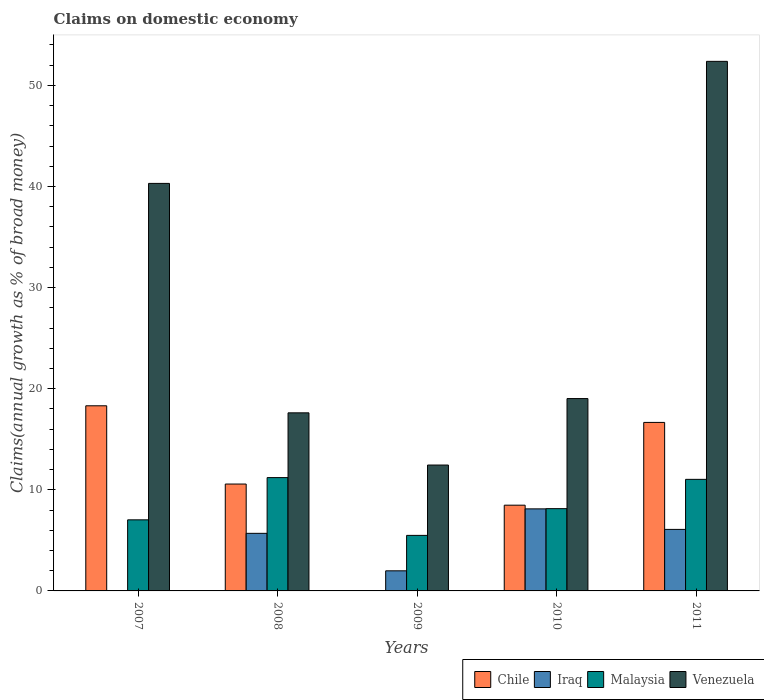How many different coloured bars are there?
Ensure brevity in your answer.  4. How many bars are there on the 5th tick from the left?
Your answer should be very brief. 4. How many bars are there on the 5th tick from the right?
Your answer should be compact. 3. In how many cases, is the number of bars for a given year not equal to the number of legend labels?
Your answer should be compact. 2. What is the percentage of broad money claimed on domestic economy in Chile in 2009?
Offer a terse response. 0. Across all years, what is the maximum percentage of broad money claimed on domestic economy in Venezuela?
Make the answer very short. 52.38. What is the total percentage of broad money claimed on domestic economy in Chile in the graph?
Give a very brief answer. 54.03. What is the difference between the percentage of broad money claimed on domestic economy in Malaysia in 2010 and that in 2011?
Offer a terse response. -2.9. What is the difference between the percentage of broad money claimed on domestic economy in Venezuela in 2008 and the percentage of broad money claimed on domestic economy in Malaysia in 2010?
Give a very brief answer. 9.48. What is the average percentage of broad money claimed on domestic economy in Malaysia per year?
Your answer should be very brief. 8.58. In the year 2011, what is the difference between the percentage of broad money claimed on domestic economy in Venezuela and percentage of broad money claimed on domestic economy in Chile?
Provide a short and direct response. 35.71. In how many years, is the percentage of broad money claimed on domestic economy in Chile greater than 2 %?
Ensure brevity in your answer.  4. What is the ratio of the percentage of broad money claimed on domestic economy in Malaysia in 2007 to that in 2008?
Make the answer very short. 0.63. Is the percentage of broad money claimed on domestic economy in Iraq in 2010 less than that in 2011?
Offer a terse response. No. Is the difference between the percentage of broad money claimed on domestic economy in Venezuela in 2007 and 2008 greater than the difference between the percentage of broad money claimed on domestic economy in Chile in 2007 and 2008?
Offer a terse response. Yes. What is the difference between the highest and the second highest percentage of broad money claimed on domestic economy in Iraq?
Your answer should be very brief. 2.03. What is the difference between the highest and the lowest percentage of broad money claimed on domestic economy in Chile?
Your response must be concise. 18.31. Is the sum of the percentage of broad money claimed on domestic economy in Venezuela in 2008 and 2009 greater than the maximum percentage of broad money claimed on domestic economy in Malaysia across all years?
Make the answer very short. Yes. Is it the case that in every year, the sum of the percentage of broad money claimed on domestic economy in Malaysia and percentage of broad money claimed on domestic economy in Iraq is greater than the percentage of broad money claimed on domestic economy in Venezuela?
Give a very brief answer. No. How many bars are there?
Your response must be concise. 18. How many years are there in the graph?
Make the answer very short. 5. What is the difference between two consecutive major ticks on the Y-axis?
Make the answer very short. 10. Does the graph contain grids?
Keep it short and to the point. No. Where does the legend appear in the graph?
Offer a very short reply. Bottom right. How many legend labels are there?
Your answer should be compact. 4. What is the title of the graph?
Your answer should be very brief. Claims on domestic economy. What is the label or title of the X-axis?
Keep it short and to the point. Years. What is the label or title of the Y-axis?
Offer a very short reply. Claims(annual growth as % of broad money). What is the Claims(annual growth as % of broad money) of Chile in 2007?
Your answer should be compact. 18.31. What is the Claims(annual growth as % of broad money) in Iraq in 2007?
Give a very brief answer. 0. What is the Claims(annual growth as % of broad money) in Malaysia in 2007?
Ensure brevity in your answer.  7.03. What is the Claims(annual growth as % of broad money) in Venezuela in 2007?
Your answer should be compact. 40.31. What is the Claims(annual growth as % of broad money) of Chile in 2008?
Your answer should be very brief. 10.57. What is the Claims(annual growth as % of broad money) of Iraq in 2008?
Ensure brevity in your answer.  5.7. What is the Claims(annual growth as % of broad money) of Malaysia in 2008?
Offer a very short reply. 11.21. What is the Claims(annual growth as % of broad money) in Venezuela in 2008?
Ensure brevity in your answer.  17.61. What is the Claims(annual growth as % of broad money) in Chile in 2009?
Ensure brevity in your answer.  0. What is the Claims(annual growth as % of broad money) in Iraq in 2009?
Keep it short and to the point. 1.99. What is the Claims(annual growth as % of broad money) in Malaysia in 2009?
Provide a succinct answer. 5.49. What is the Claims(annual growth as % of broad money) in Venezuela in 2009?
Provide a succinct answer. 12.45. What is the Claims(annual growth as % of broad money) in Chile in 2010?
Ensure brevity in your answer.  8.48. What is the Claims(annual growth as % of broad money) in Iraq in 2010?
Make the answer very short. 8.12. What is the Claims(annual growth as % of broad money) in Malaysia in 2010?
Provide a short and direct response. 8.14. What is the Claims(annual growth as % of broad money) of Venezuela in 2010?
Give a very brief answer. 19.03. What is the Claims(annual growth as % of broad money) in Chile in 2011?
Keep it short and to the point. 16.67. What is the Claims(annual growth as % of broad money) of Iraq in 2011?
Your answer should be compact. 6.09. What is the Claims(annual growth as % of broad money) in Malaysia in 2011?
Provide a short and direct response. 11.04. What is the Claims(annual growth as % of broad money) of Venezuela in 2011?
Provide a succinct answer. 52.38. Across all years, what is the maximum Claims(annual growth as % of broad money) of Chile?
Your response must be concise. 18.31. Across all years, what is the maximum Claims(annual growth as % of broad money) of Iraq?
Provide a succinct answer. 8.12. Across all years, what is the maximum Claims(annual growth as % of broad money) of Malaysia?
Provide a short and direct response. 11.21. Across all years, what is the maximum Claims(annual growth as % of broad money) of Venezuela?
Provide a succinct answer. 52.38. Across all years, what is the minimum Claims(annual growth as % of broad money) of Chile?
Your answer should be compact. 0. Across all years, what is the minimum Claims(annual growth as % of broad money) in Iraq?
Your answer should be compact. 0. Across all years, what is the minimum Claims(annual growth as % of broad money) in Malaysia?
Keep it short and to the point. 5.49. Across all years, what is the minimum Claims(annual growth as % of broad money) in Venezuela?
Ensure brevity in your answer.  12.45. What is the total Claims(annual growth as % of broad money) of Chile in the graph?
Keep it short and to the point. 54.03. What is the total Claims(annual growth as % of broad money) in Iraq in the graph?
Your answer should be compact. 21.88. What is the total Claims(annual growth as % of broad money) in Malaysia in the graph?
Offer a very short reply. 42.9. What is the total Claims(annual growth as % of broad money) in Venezuela in the graph?
Give a very brief answer. 141.78. What is the difference between the Claims(annual growth as % of broad money) in Chile in 2007 and that in 2008?
Your response must be concise. 7.74. What is the difference between the Claims(annual growth as % of broad money) of Malaysia in 2007 and that in 2008?
Provide a succinct answer. -4.18. What is the difference between the Claims(annual growth as % of broad money) in Venezuela in 2007 and that in 2008?
Provide a succinct answer. 22.69. What is the difference between the Claims(annual growth as % of broad money) in Malaysia in 2007 and that in 2009?
Make the answer very short. 1.54. What is the difference between the Claims(annual growth as % of broad money) in Venezuela in 2007 and that in 2009?
Provide a succinct answer. 27.86. What is the difference between the Claims(annual growth as % of broad money) of Chile in 2007 and that in 2010?
Your answer should be compact. 9.83. What is the difference between the Claims(annual growth as % of broad money) in Malaysia in 2007 and that in 2010?
Your response must be concise. -1.11. What is the difference between the Claims(annual growth as % of broad money) of Venezuela in 2007 and that in 2010?
Your answer should be compact. 21.28. What is the difference between the Claims(annual growth as % of broad money) in Chile in 2007 and that in 2011?
Provide a short and direct response. 1.65. What is the difference between the Claims(annual growth as % of broad money) in Malaysia in 2007 and that in 2011?
Offer a very short reply. -4.01. What is the difference between the Claims(annual growth as % of broad money) in Venezuela in 2007 and that in 2011?
Your answer should be compact. -12.07. What is the difference between the Claims(annual growth as % of broad money) in Iraq in 2008 and that in 2009?
Your answer should be compact. 3.71. What is the difference between the Claims(annual growth as % of broad money) of Malaysia in 2008 and that in 2009?
Ensure brevity in your answer.  5.72. What is the difference between the Claims(annual growth as % of broad money) of Venezuela in 2008 and that in 2009?
Your response must be concise. 5.16. What is the difference between the Claims(annual growth as % of broad money) of Chile in 2008 and that in 2010?
Keep it short and to the point. 2.09. What is the difference between the Claims(annual growth as % of broad money) of Iraq in 2008 and that in 2010?
Provide a succinct answer. -2.42. What is the difference between the Claims(annual growth as % of broad money) in Malaysia in 2008 and that in 2010?
Make the answer very short. 3.07. What is the difference between the Claims(annual growth as % of broad money) in Venezuela in 2008 and that in 2010?
Offer a very short reply. -1.41. What is the difference between the Claims(annual growth as % of broad money) of Chile in 2008 and that in 2011?
Keep it short and to the point. -6.09. What is the difference between the Claims(annual growth as % of broad money) in Iraq in 2008 and that in 2011?
Your answer should be very brief. -0.39. What is the difference between the Claims(annual growth as % of broad money) in Malaysia in 2008 and that in 2011?
Provide a short and direct response. 0.17. What is the difference between the Claims(annual growth as % of broad money) in Venezuela in 2008 and that in 2011?
Your response must be concise. -34.77. What is the difference between the Claims(annual growth as % of broad money) in Iraq in 2009 and that in 2010?
Offer a very short reply. -6.13. What is the difference between the Claims(annual growth as % of broad money) in Malaysia in 2009 and that in 2010?
Your answer should be compact. -2.64. What is the difference between the Claims(annual growth as % of broad money) of Venezuela in 2009 and that in 2010?
Your answer should be compact. -6.57. What is the difference between the Claims(annual growth as % of broad money) of Iraq in 2009 and that in 2011?
Give a very brief answer. -4.1. What is the difference between the Claims(annual growth as % of broad money) in Malaysia in 2009 and that in 2011?
Your response must be concise. -5.54. What is the difference between the Claims(annual growth as % of broad money) in Venezuela in 2009 and that in 2011?
Provide a succinct answer. -39.93. What is the difference between the Claims(annual growth as % of broad money) of Chile in 2010 and that in 2011?
Provide a succinct answer. -8.19. What is the difference between the Claims(annual growth as % of broad money) in Iraq in 2010 and that in 2011?
Your response must be concise. 2.03. What is the difference between the Claims(annual growth as % of broad money) of Malaysia in 2010 and that in 2011?
Make the answer very short. -2.9. What is the difference between the Claims(annual growth as % of broad money) in Venezuela in 2010 and that in 2011?
Your answer should be very brief. -33.35. What is the difference between the Claims(annual growth as % of broad money) in Chile in 2007 and the Claims(annual growth as % of broad money) in Iraq in 2008?
Offer a terse response. 12.62. What is the difference between the Claims(annual growth as % of broad money) in Chile in 2007 and the Claims(annual growth as % of broad money) in Malaysia in 2008?
Your answer should be compact. 7.1. What is the difference between the Claims(annual growth as % of broad money) of Chile in 2007 and the Claims(annual growth as % of broad money) of Venezuela in 2008?
Provide a succinct answer. 0.7. What is the difference between the Claims(annual growth as % of broad money) in Malaysia in 2007 and the Claims(annual growth as % of broad money) in Venezuela in 2008?
Ensure brevity in your answer.  -10.58. What is the difference between the Claims(annual growth as % of broad money) of Chile in 2007 and the Claims(annual growth as % of broad money) of Iraq in 2009?
Ensure brevity in your answer.  16.32. What is the difference between the Claims(annual growth as % of broad money) in Chile in 2007 and the Claims(annual growth as % of broad money) in Malaysia in 2009?
Ensure brevity in your answer.  12.82. What is the difference between the Claims(annual growth as % of broad money) of Chile in 2007 and the Claims(annual growth as % of broad money) of Venezuela in 2009?
Offer a terse response. 5.86. What is the difference between the Claims(annual growth as % of broad money) in Malaysia in 2007 and the Claims(annual growth as % of broad money) in Venezuela in 2009?
Give a very brief answer. -5.42. What is the difference between the Claims(annual growth as % of broad money) of Chile in 2007 and the Claims(annual growth as % of broad money) of Iraq in 2010?
Offer a very short reply. 10.2. What is the difference between the Claims(annual growth as % of broad money) in Chile in 2007 and the Claims(annual growth as % of broad money) in Malaysia in 2010?
Your answer should be compact. 10.17. What is the difference between the Claims(annual growth as % of broad money) in Chile in 2007 and the Claims(annual growth as % of broad money) in Venezuela in 2010?
Provide a succinct answer. -0.71. What is the difference between the Claims(annual growth as % of broad money) of Malaysia in 2007 and the Claims(annual growth as % of broad money) of Venezuela in 2010?
Provide a succinct answer. -12. What is the difference between the Claims(annual growth as % of broad money) in Chile in 2007 and the Claims(annual growth as % of broad money) in Iraq in 2011?
Keep it short and to the point. 12.23. What is the difference between the Claims(annual growth as % of broad money) in Chile in 2007 and the Claims(annual growth as % of broad money) in Malaysia in 2011?
Provide a short and direct response. 7.28. What is the difference between the Claims(annual growth as % of broad money) in Chile in 2007 and the Claims(annual growth as % of broad money) in Venezuela in 2011?
Your answer should be very brief. -34.07. What is the difference between the Claims(annual growth as % of broad money) of Malaysia in 2007 and the Claims(annual growth as % of broad money) of Venezuela in 2011?
Keep it short and to the point. -45.35. What is the difference between the Claims(annual growth as % of broad money) in Chile in 2008 and the Claims(annual growth as % of broad money) in Iraq in 2009?
Give a very brief answer. 8.58. What is the difference between the Claims(annual growth as % of broad money) in Chile in 2008 and the Claims(annual growth as % of broad money) in Malaysia in 2009?
Give a very brief answer. 5.08. What is the difference between the Claims(annual growth as % of broad money) of Chile in 2008 and the Claims(annual growth as % of broad money) of Venezuela in 2009?
Ensure brevity in your answer.  -1.88. What is the difference between the Claims(annual growth as % of broad money) in Iraq in 2008 and the Claims(annual growth as % of broad money) in Malaysia in 2009?
Provide a succinct answer. 0.2. What is the difference between the Claims(annual growth as % of broad money) of Iraq in 2008 and the Claims(annual growth as % of broad money) of Venezuela in 2009?
Your response must be concise. -6.76. What is the difference between the Claims(annual growth as % of broad money) in Malaysia in 2008 and the Claims(annual growth as % of broad money) in Venezuela in 2009?
Ensure brevity in your answer.  -1.24. What is the difference between the Claims(annual growth as % of broad money) in Chile in 2008 and the Claims(annual growth as % of broad money) in Iraq in 2010?
Keep it short and to the point. 2.46. What is the difference between the Claims(annual growth as % of broad money) in Chile in 2008 and the Claims(annual growth as % of broad money) in Malaysia in 2010?
Your response must be concise. 2.43. What is the difference between the Claims(annual growth as % of broad money) of Chile in 2008 and the Claims(annual growth as % of broad money) of Venezuela in 2010?
Make the answer very short. -8.45. What is the difference between the Claims(annual growth as % of broad money) of Iraq in 2008 and the Claims(annual growth as % of broad money) of Malaysia in 2010?
Ensure brevity in your answer.  -2.44. What is the difference between the Claims(annual growth as % of broad money) in Iraq in 2008 and the Claims(annual growth as % of broad money) in Venezuela in 2010?
Provide a short and direct response. -13.33. What is the difference between the Claims(annual growth as % of broad money) in Malaysia in 2008 and the Claims(annual growth as % of broad money) in Venezuela in 2010?
Offer a very short reply. -7.82. What is the difference between the Claims(annual growth as % of broad money) in Chile in 2008 and the Claims(annual growth as % of broad money) in Iraq in 2011?
Give a very brief answer. 4.49. What is the difference between the Claims(annual growth as % of broad money) in Chile in 2008 and the Claims(annual growth as % of broad money) in Malaysia in 2011?
Provide a short and direct response. -0.46. What is the difference between the Claims(annual growth as % of broad money) of Chile in 2008 and the Claims(annual growth as % of broad money) of Venezuela in 2011?
Your response must be concise. -41.81. What is the difference between the Claims(annual growth as % of broad money) of Iraq in 2008 and the Claims(annual growth as % of broad money) of Malaysia in 2011?
Your answer should be very brief. -5.34. What is the difference between the Claims(annual growth as % of broad money) in Iraq in 2008 and the Claims(annual growth as % of broad money) in Venezuela in 2011?
Give a very brief answer. -46.68. What is the difference between the Claims(annual growth as % of broad money) in Malaysia in 2008 and the Claims(annual growth as % of broad money) in Venezuela in 2011?
Make the answer very short. -41.17. What is the difference between the Claims(annual growth as % of broad money) of Iraq in 2009 and the Claims(annual growth as % of broad money) of Malaysia in 2010?
Make the answer very short. -6.15. What is the difference between the Claims(annual growth as % of broad money) in Iraq in 2009 and the Claims(annual growth as % of broad money) in Venezuela in 2010?
Your answer should be compact. -17.04. What is the difference between the Claims(annual growth as % of broad money) in Malaysia in 2009 and the Claims(annual growth as % of broad money) in Venezuela in 2010?
Your answer should be very brief. -13.53. What is the difference between the Claims(annual growth as % of broad money) in Iraq in 2009 and the Claims(annual growth as % of broad money) in Malaysia in 2011?
Make the answer very short. -9.05. What is the difference between the Claims(annual growth as % of broad money) of Iraq in 2009 and the Claims(annual growth as % of broad money) of Venezuela in 2011?
Give a very brief answer. -50.39. What is the difference between the Claims(annual growth as % of broad money) in Malaysia in 2009 and the Claims(annual growth as % of broad money) in Venezuela in 2011?
Your response must be concise. -46.89. What is the difference between the Claims(annual growth as % of broad money) of Chile in 2010 and the Claims(annual growth as % of broad money) of Iraq in 2011?
Your answer should be compact. 2.4. What is the difference between the Claims(annual growth as % of broad money) in Chile in 2010 and the Claims(annual growth as % of broad money) in Malaysia in 2011?
Provide a succinct answer. -2.55. What is the difference between the Claims(annual growth as % of broad money) of Chile in 2010 and the Claims(annual growth as % of broad money) of Venezuela in 2011?
Provide a succinct answer. -43.9. What is the difference between the Claims(annual growth as % of broad money) in Iraq in 2010 and the Claims(annual growth as % of broad money) in Malaysia in 2011?
Ensure brevity in your answer.  -2.92. What is the difference between the Claims(annual growth as % of broad money) in Iraq in 2010 and the Claims(annual growth as % of broad money) in Venezuela in 2011?
Keep it short and to the point. -44.26. What is the difference between the Claims(annual growth as % of broad money) of Malaysia in 2010 and the Claims(annual growth as % of broad money) of Venezuela in 2011?
Ensure brevity in your answer.  -44.24. What is the average Claims(annual growth as % of broad money) in Chile per year?
Ensure brevity in your answer.  10.81. What is the average Claims(annual growth as % of broad money) in Iraq per year?
Make the answer very short. 4.38. What is the average Claims(annual growth as % of broad money) in Malaysia per year?
Your answer should be very brief. 8.58. What is the average Claims(annual growth as % of broad money) in Venezuela per year?
Offer a very short reply. 28.36. In the year 2007, what is the difference between the Claims(annual growth as % of broad money) in Chile and Claims(annual growth as % of broad money) in Malaysia?
Your response must be concise. 11.28. In the year 2007, what is the difference between the Claims(annual growth as % of broad money) of Chile and Claims(annual growth as % of broad money) of Venezuela?
Your response must be concise. -22. In the year 2007, what is the difference between the Claims(annual growth as % of broad money) of Malaysia and Claims(annual growth as % of broad money) of Venezuela?
Ensure brevity in your answer.  -33.28. In the year 2008, what is the difference between the Claims(annual growth as % of broad money) in Chile and Claims(annual growth as % of broad money) in Iraq?
Make the answer very short. 4.88. In the year 2008, what is the difference between the Claims(annual growth as % of broad money) of Chile and Claims(annual growth as % of broad money) of Malaysia?
Provide a short and direct response. -0.64. In the year 2008, what is the difference between the Claims(annual growth as % of broad money) of Chile and Claims(annual growth as % of broad money) of Venezuela?
Ensure brevity in your answer.  -7.04. In the year 2008, what is the difference between the Claims(annual growth as % of broad money) of Iraq and Claims(annual growth as % of broad money) of Malaysia?
Ensure brevity in your answer.  -5.51. In the year 2008, what is the difference between the Claims(annual growth as % of broad money) in Iraq and Claims(annual growth as % of broad money) in Venezuela?
Your answer should be very brief. -11.92. In the year 2008, what is the difference between the Claims(annual growth as % of broad money) in Malaysia and Claims(annual growth as % of broad money) in Venezuela?
Offer a very short reply. -6.41. In the year 2009, what is the difference between the Claims(annual growth as % of broad money) of Iraq and Claims(annual growth as % of broad money) of Malaysia?
Provide a short and direct response. -3.5. In the year 2009, what is the difference between the Claims(annual growth as % of broad money) in Iraq and Claims(annual growth as % of broad money) in Venezuela?
Offer a terse response. -10.46. In the year 2009, what is the difference between the Claims(annual growth as % of broad money) of Malaysia and Claims(annual growth as % of broad money) of Venezuela?
Provide a succinct answer. -6.96. In the year 2010, what is the difference between the Claims(annual growth as % of broad money) of Chile and Claims(annual growth as % of broad money) of Iraq?
Your answer should be compact. 0.37. In the year 2010, what is the difference between the Claims(annual growth as % of broad money) in Chile and Claims(annual growth as % of broad money) in Malaysia?
Your answer should be very brief. 0.34. In the year 2010, what is the difference between the Claims(annual growth as % of broad money) of Chile and Claims(annual growth as % of broad money) of Venezuela?
Make the answer very short. -10.54. In the year 2010, what is the difference between the Claims(annual growth as % of broad money) in Iraq and Claims(annual growth as % of broad money) in Malaysia?
Make the answer very short. -0.02. In the year 2010, what is the difference between the Claims(annual growth as % of broad money) in Iraq and Claims(annual growth as % of broad money) in Venezuela?
Your answer should be very brief. -10.91. In the year 2010, what is the difference between the Claims(annual growth as % of broad money) of Malaysia and Claims(annual growth as % of broad money) of Venezuela?
Offer a terse response. -10.89. In the year 2011, what is the difference between the Claims(annual growth as % of broad money) of Chile and Claims(annual growth as % of broad money) of Iraq?
Keep it short and to the point. 10.58. In the year 2011, what is the difference between the Claims(annual growth as % of broad money) in Chile and Claims(annual growth as % of broad money) in Malaysia?
Your answer should be very brief. 5.63. In the year 2011, what is the difference between the Claims(annual growth as % of broad money) of Chile and Claims(annual growth as % of broad money) of Venezuela?
Your response must be concise. -35.71. In the year 2011, what is the difference between the Claims(annual growth as % of broad money) of Iraq and Claims(annual growth as % of broad money) of Malaysia?
Your response must be concise. -4.95. In the year 2011, what is the difference between the Claims(annual growth as % of broad money) in Iraq and Claims(annual growth as % of broad money) in Venezuela?
Make the answer very short. -46.29. In the year 2011, what is the difference between the Claims(annual growth as % of broad money) in Malaysia and Claims(annual growth as % of broad money) in Venezuela?
Give a very brief answer. -41.34. What is the ratio of the Claims(annual growth as % of broad money) in Chile in 2007 to that in 2008?
Provide a short and direct response. 1.73. What is the ratio of the Claims(annual growth as % of broad money) of Malaysia in 2007 to that in 2008?
Keep it short and to the point. 0.63. What is the ratio of the Claims(annual growth as % of broad money) of Venezuela in 2007 to that in 2008?
Provide a short and direct response. 2.29. What is the ratio of the Claims(annual growth as % of broad money) in Malaysia in 2007 to that in 2009?
Provide a succinct answer. 1.28. What is the ratio of the Claims(annual growth as % of broad money) in Venezuela in 2007 to that in 2009?
Your answer should be compact. 3.24. What is the ratio of the Claims(annual growth as % of broad money) in Chile in 2007 to that in 2010?
Offer a very short reply. 2.16. What is the ratio of the Claims(annual growth as % of broad money) of Malaysia in 2007 to that in 2010?
Give a very brief answer. 0.86. What is the ratio of the Claims(annual growth as % of broad money) in Venezuela in 2007 to that in 2010?
Keep it short and to the point. 2.12. What is the ratio of the Claims(annual growth as % of broad money) of Chile in 2007 to that in 2011?
Give a very brief answer. 1.1. What is the ratio of the Claims(annual growth as % of broad money) of Malaysia in 2007 to that in 2011?
Your answer should be very brief. 0.64. What is the ratio of the Claims(annual growth as % of broad money) of Venezuela in 2007 to that in 2011?
Your answer should be very brief. 0.77. What is the ratio of the Claims(annual growth as % of broad money) of Iraq in 2008 to that in 2009?
Make the answer very short. 2.86. What is the ratio of the Claims(annual growth as % of broad money) in Malaysia in 2008 to that in 2009?
Your answer should be compact. 2.04. What is the ratio of the Claims(annual growth as % of broad money) in Venezuela in 2008 to that in 2009?
Your response must be concise. 1.41. What is the ratio of the Claims(annual growth as % of broad money) in Chile in 2008 to that in 2010?
Your response must be concise. 1.25. What is the ratio of the Claims(annual growth as % of broad money) of Iraq in 2008 to that in 2010?
Your answer should be very brief. 0.7. What is the ratio of the Claims(annual growth as % of broad money) in Malaysia in 2008 to that in 2010?
Your answer should be compact. 1.38. What is the ratio of the Claims(annual growth as % of broad money) of Venezuela in 2008 to that in 2010?
Your answer should be very brief. 0.93. What is the ratio of the Claims(annual growth as % of broad money) of Chile in 2008 to that in 2011?
Offer a very short reply. 0.63. What is the ratio of the Claims(annual growth as % of broad money) of Iraq in 2008 to that in 2011?
Make the answer very short. 0.94. What is the ratio of the Claims(annual growth as % of broad money) of Malaysia in 2008 to that in 2011?
Your answer should be very brief. 1.02. What is the ratio of the Claims(annual growth as % of broad money) in Venezuela in 2008 to that in 2011?
Give a very brief answer. 0.34. What is the ratio of the Claims(annual growth as % of broad money) of Iraq in 2009 to that in 2010?
Give a very brief answer. 0.24. What is the ratio of the Claims(annual growth as % of broad money) in Malaysia in 2009 to that in 2010?
Keep it short and to the point. 0.68. What is the ratio of the Claims(annual growth as % of broad money) in Venezuela in 2009 to that in 2010?
Your answer should be very brief. 0.65. What is the ratio of the Claims(annual growth as % of broad money) of Iraq in 2009 to that in 2011?
Keep it short and to the point. 0.33. What is the ratio of the Claims(annual growth as % of broad money) in Malaysia in 2009 to that in 2011?
Your answer should be compact. 0.5. What is the ratio of the Claims(annual growth as % of broad money) in Venezuela in 2009 to that in 2011?
Your answer should be compact. 0.24. What is the ratio of the Claims(annual growth as % of broad money) in Chile in 2010 to that in 2011?
Offer a terse response. 0.51. What is the ratio of the Claims(annual growth as % of broad money) in Iraq in 2010 to that in 2011?
Keep it short and to the point. 1.33. What is the ratio of the Claims(annual growth as % of broad money) in Malaysia in 2010 to that in 2011?
Your response must be concise. 0.74. What is the ratio of the Claims(annual growth as % of broad money) in Venezuela in 2010 to that in 2011?
Your response must be concise. 0.36. What is the difference between the highest and the second highest Claims(annual growth as % of broad money) in Chile?
Offer a very short reply. 1.65. What is the difference between the highest and the second highest Claims(annual growth as % of broad money) of Iraq?
Provide a succinct answer. 2.03. What is the difference between the highest and the second highest Claims(annual growth as % of broad money) in Malaysia?
Provide a succinct answer. 0.17. What is the difference between the highest and the second highest Claims(annual growth as % of broad money) in Venezuela?
Give a very brief answer. 12.07. What is the difference between the highest and the lowest Claims(annual growth as % of broad money) in Chile?
Offer a terse response. 18.31. What is the difference between the highest and the lowest Claims(annual growth as % of broad money) in Iraq?
Your answer should be very brief. 8.12. What is the difference between the highest and the lowest Claims(annual growth as % of broad money) of Malaysia?
Ensure brevity in your answer.  5.72. What is the difference between the highest and the lowest Claims(annual growth as % of broad money) in Venezuela?
Ensure brevity in your answer.  39.93. 